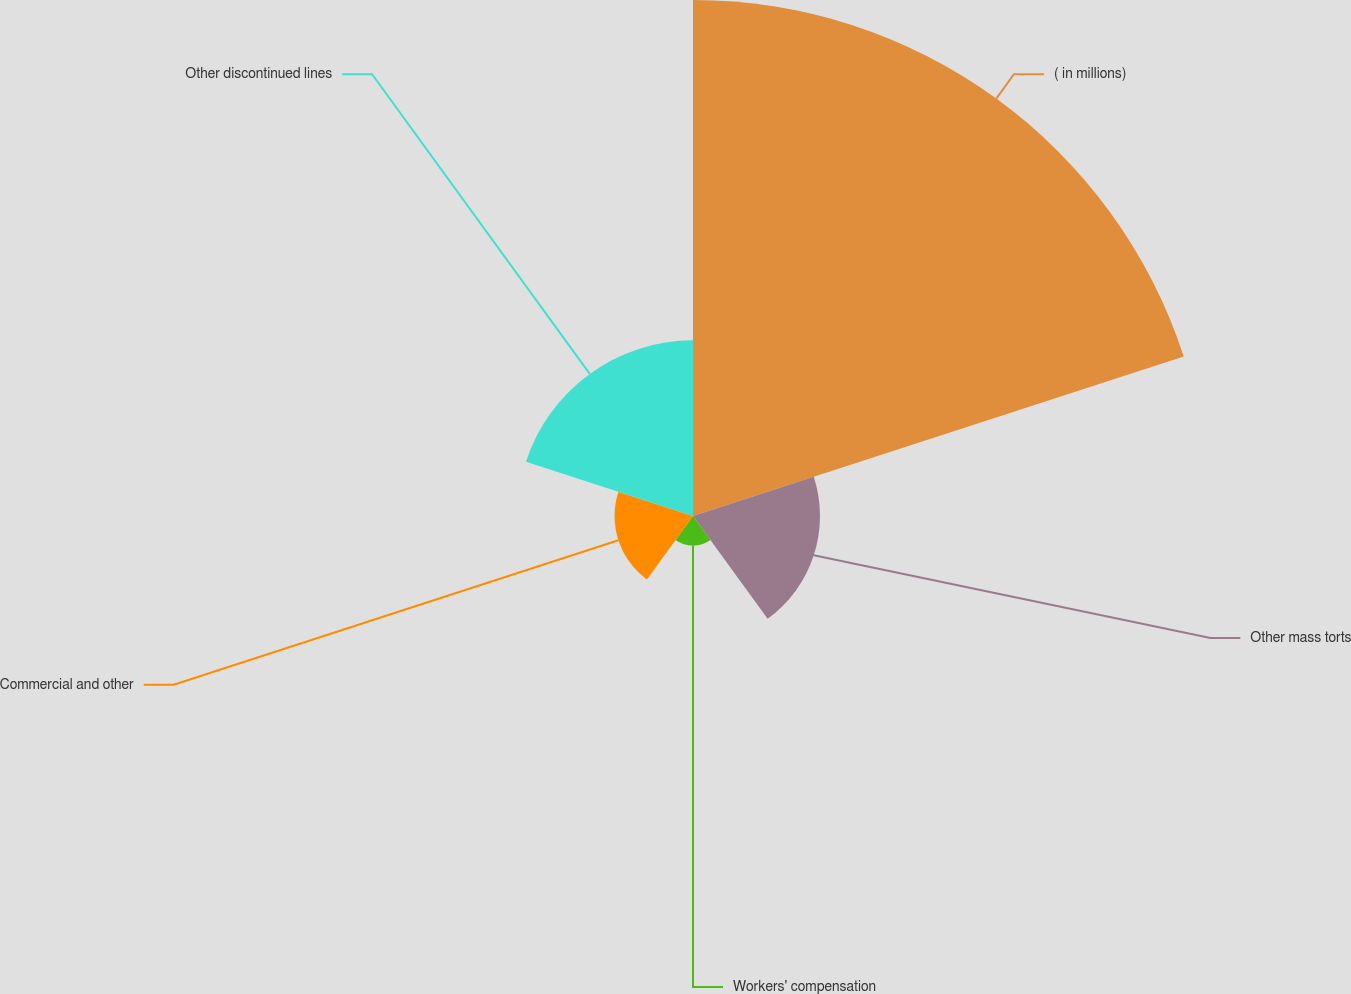<chart> <loc_0><loc_0><loc_500><loc_500><pie_chart><fcel>( in millions)<fcel>Other mass torts<fcel>Workers' compensation<fcel>Commercial and other<fcel>Other discontinued lines<nl><fcel>55.67%<fcel>13.7%<fcel>3.21%<fcel>8.46%<fcel>18.95%<nl></chart> 